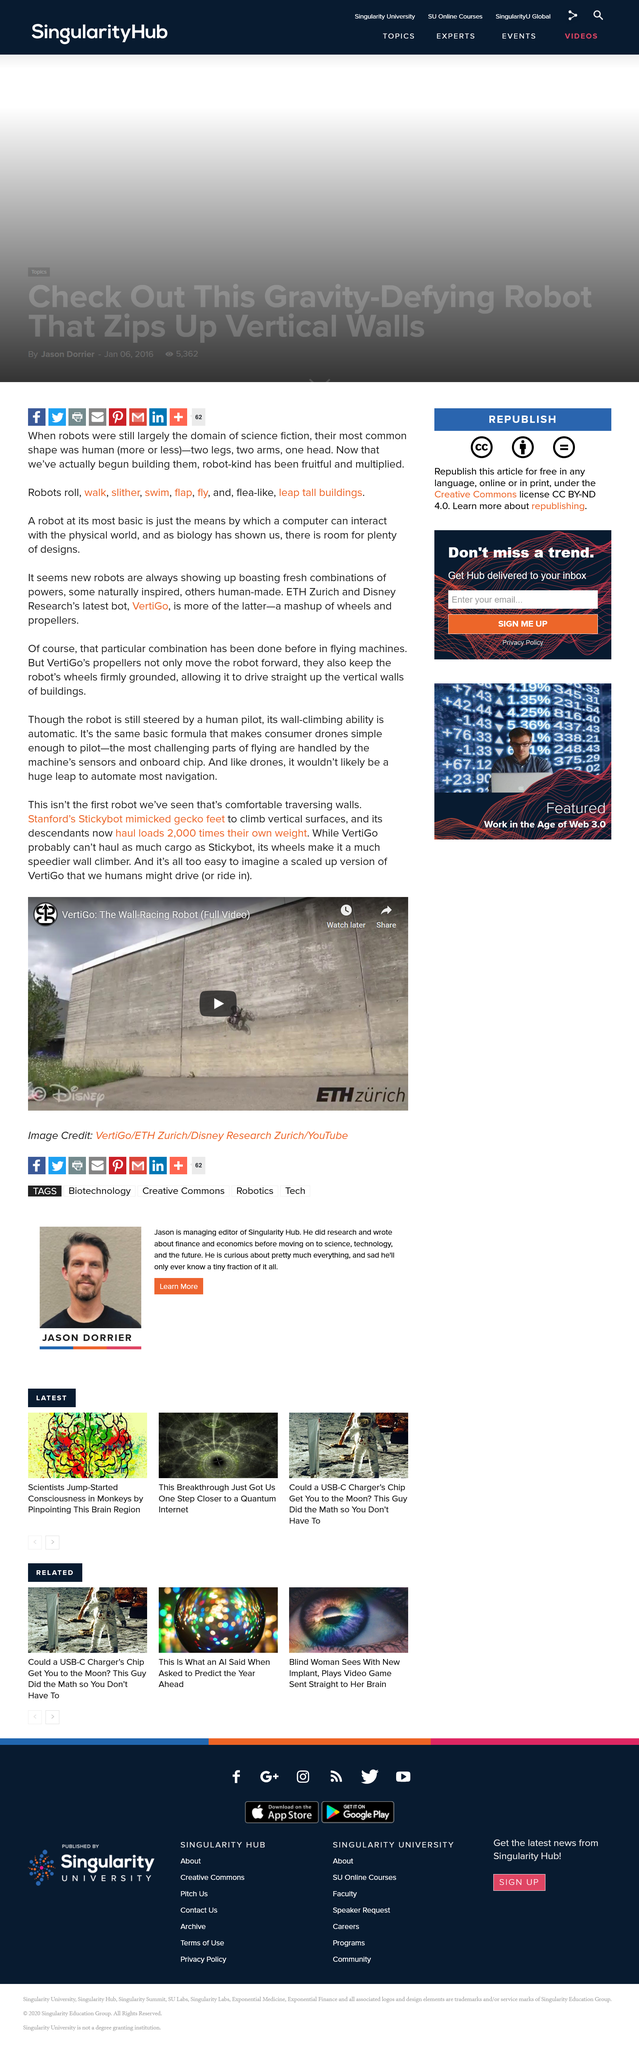Draw attention to some important aspects in this diagram. VertiGo is a unique robot that is capable of moving forward while keeping its wheels firmly on the ground. This distinguishing feature sets VertiGo apart from other robots and makes it a valuable asset in a variety of applications. The VertiGo Robot is a versatile robot that is capable of driving up vertical walls, making it an ideal solution for accessing hard-to-reach areas. The VertiGo Robot is controlled by a human pilot through precise steering. 